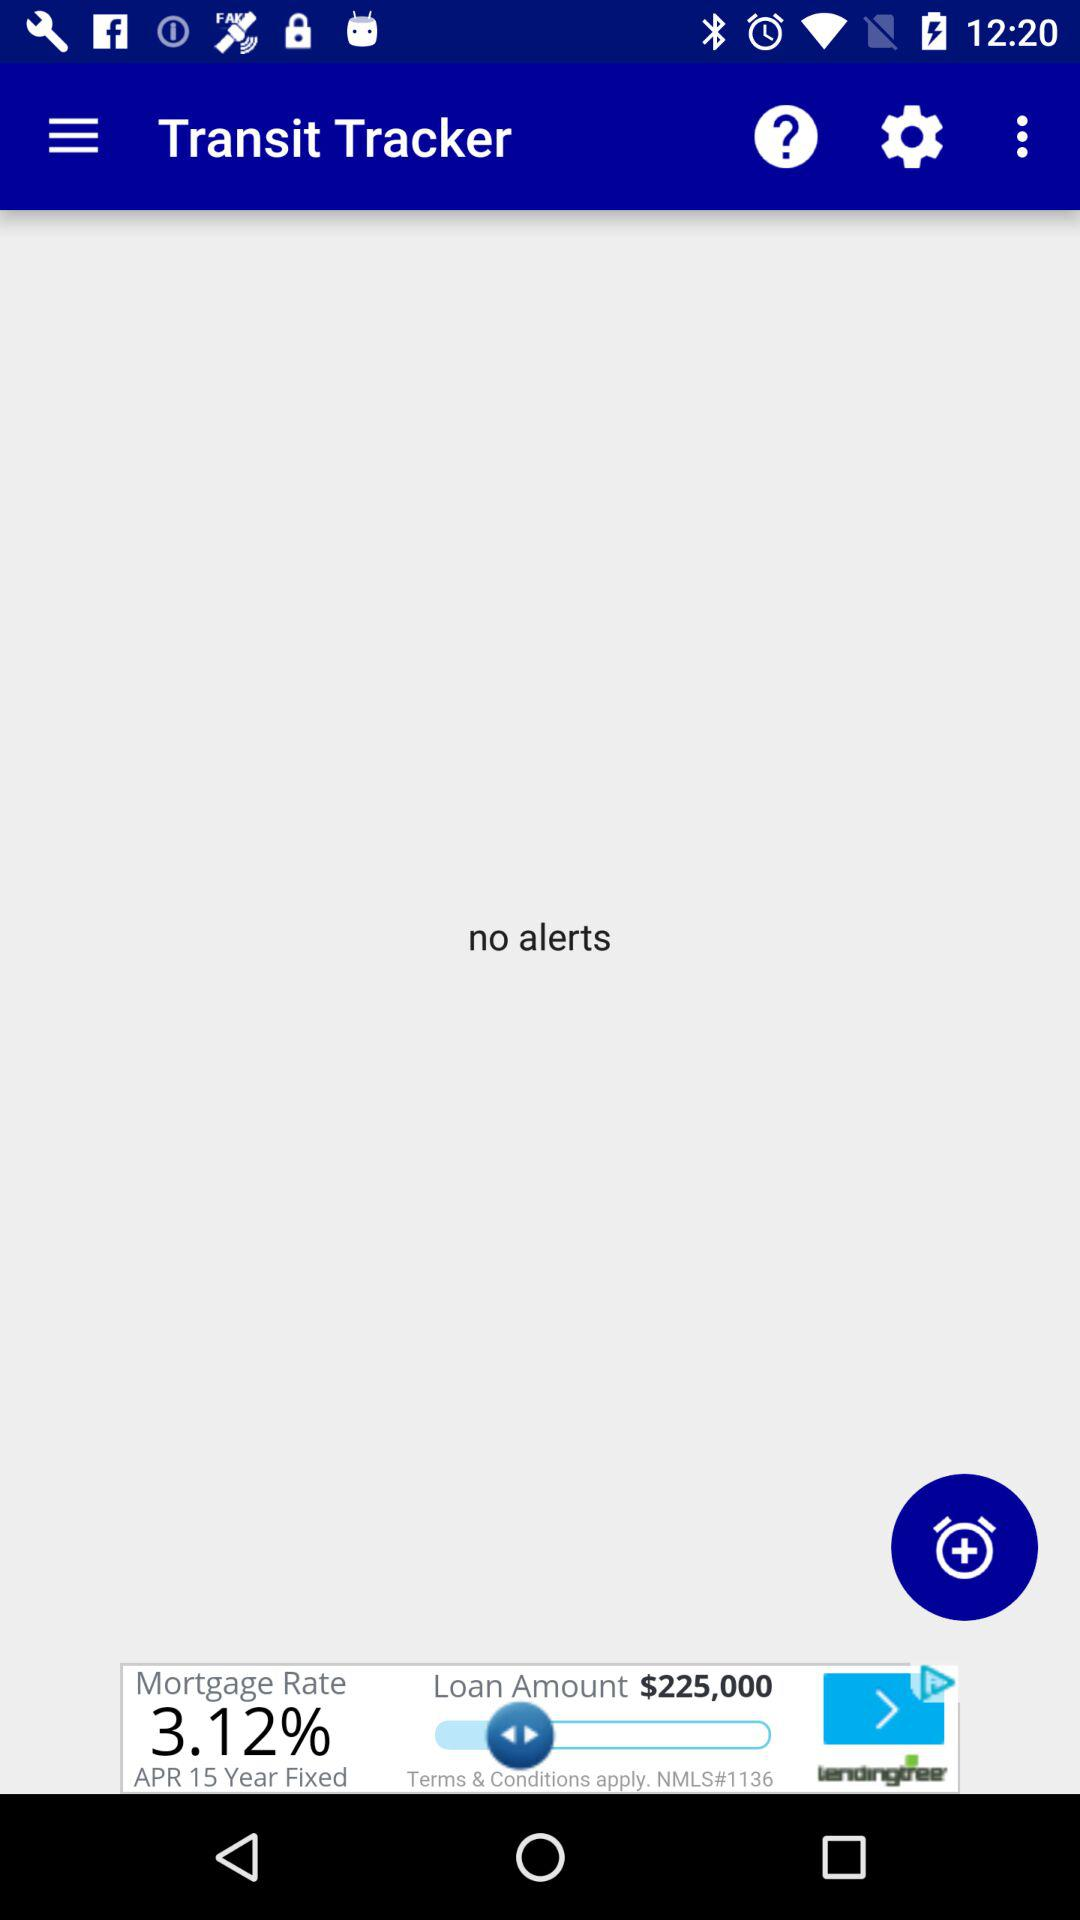Is there any alert? There is no alert. 